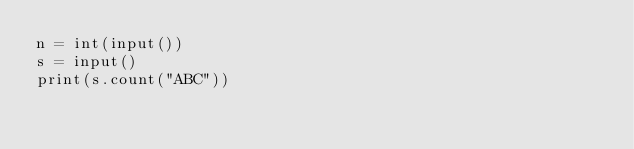Convert code to text. <code><loc_0><loc_0><loc_500><loc_500><_Python_>n = int(input())
s = input()
print(s.count("ABC"))</code> 